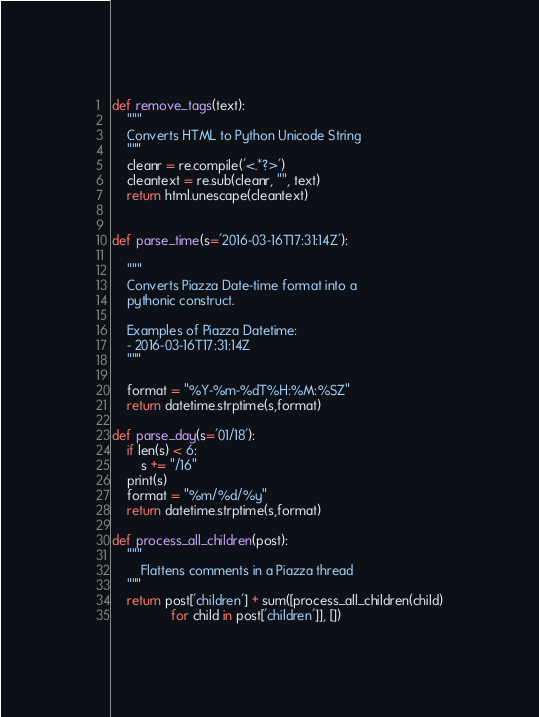<code> <loc_0><loc_0><loc_500><loc_500><_Python_>
def remove_tags(text):
    """
    Converts HTML to Python Unicode String
    """
    cleanr = re.compile('<.*?>')
    cleantext = re.sub(cleanr, "", text)
    return html.unescape(cleantext)


def parse_time(s='2016-03-16T17:31:14Z'):

    """
    Converts Piazza Date-time format into a
    pythonic construct.

    Examples of Piazza Datetime:
    - 2016-03-16T17:31:14Z
    """

    format = "%Y-%m-%dT%H:%M:%SZ"
    return datetime.strptime(s,format)

def parse_day(s='01/18'):
    if len(s) < 6:
        s += "/16"
    print(s)
    format = "%m/%d/%y"
    return datetime.strptime(s,format)

def process_all_children(post):
    """
        Flattens comments in a Piazza thread
    """
    return post['children'] + sum([process_all_children(child)
                for child in post['children']], [])
</code> 